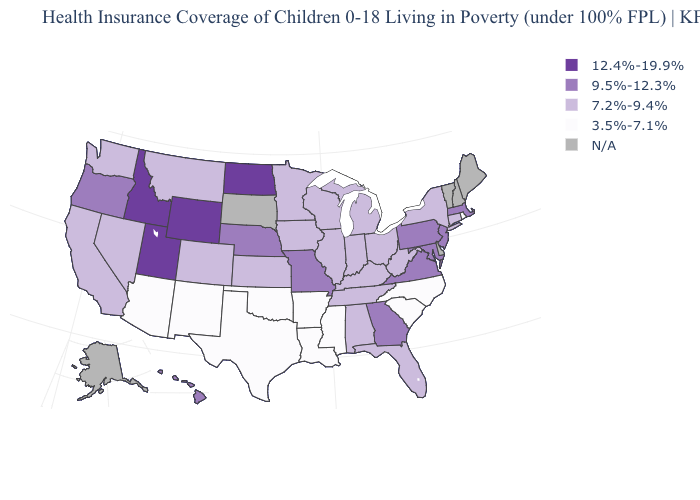What is the value of Alaska?
Be succinct. N/A. How many symbols are there in the legend?
Write a very short answer. 5. Name the states that have a value in the range 12.4%-19.9%?
Be succinct. Idaho, North Dakota, Utah, Wyoming. Name the states that have a value in the range N/A?
Short answer required. Alaska, Delaware, Maine, New Hampshire, South Dakota, Vermont. Name the states that have a value in the range 7.2%-9.4%?
Be succinct. Alabama, California, Colorado, Connecticut, Florida, Illinois, Indiana, Iowa, Kansas, Kentucky, Michigan, Minnesota, Montana, Nevada, New York, Ohio, Tennessee, Washington, West Virginia, Wisconsin. What is the highest value in the West ?
Short answer required. 12.4%-19.9%. Does the first symbol in the legend represent the smallest category?
Short answer required. No. Does Iowa have the lowest value in the USA?
Answer briefly. No. Among the states that border Oregon , which have the lowest value?
Be succinct. California, Nevada, Washington. What is the value of Connecticut?
Be succinct. 7.2%-9.4%. Does the map have missing data?
Concise answer only. Yes. Which states have the lowest value in the USA?
Quick response, please. Arizona, Arkansas, Louisiana, Mississippi, New Mexico, North Carolina, Oklahoma, Rhode Island, South Carolina, Texas. What is the value of Ohio?
Be succinct. 7.2%-9.4%. Does Idaho have the highest value in the USA?
Write a very short answer. Yes. Is the legend a continuous bar?
Concise answer only. No. 